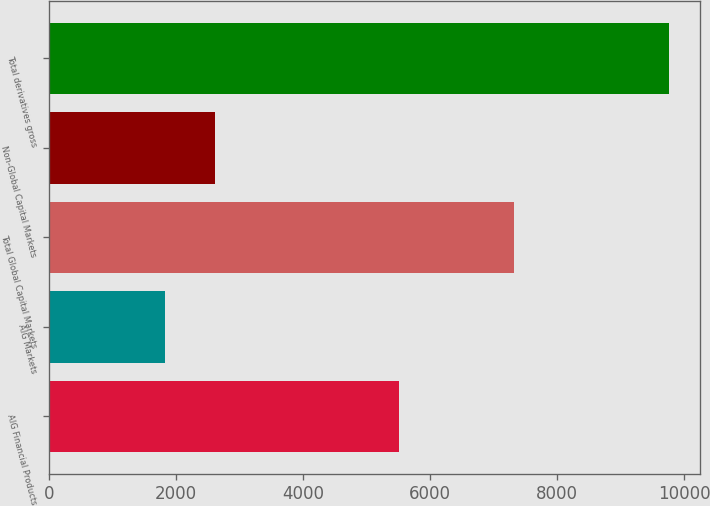Convert chart. <chart><loc_0><loc_0><loc_500><loc_500><bar_chart><fcel>AIG Financial Products<fcel>AIG Markets<fcel>Total Global Capital Markets<fcel>Non-Global Capital Markets<fcel>Total derivatives gross<nl><fcel>5506<fcel>1818<fcel>7324<fcel>2612.2<fcel>9760<nl></chart> 